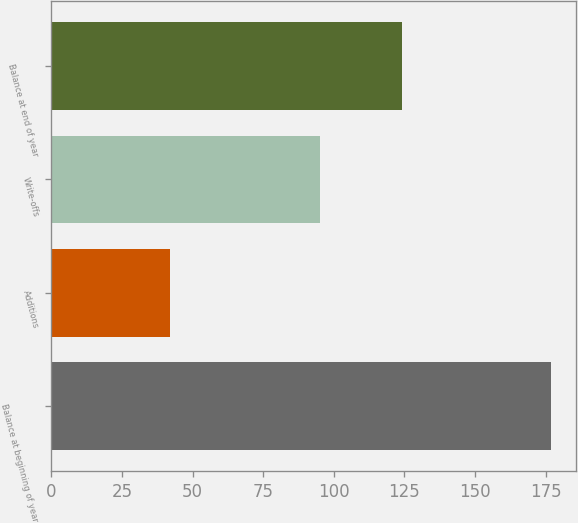Convert chart. <chart><loc_0><loc_0><loc_500><loc_500><bar_chart><fcel>Balance at beginning of year<fcel>Additions<fcel>Write-offs<fcel>Balance at end of year<nl><fcel>177<fcel>42<fcel>95<fcel>124<nl></chart> 